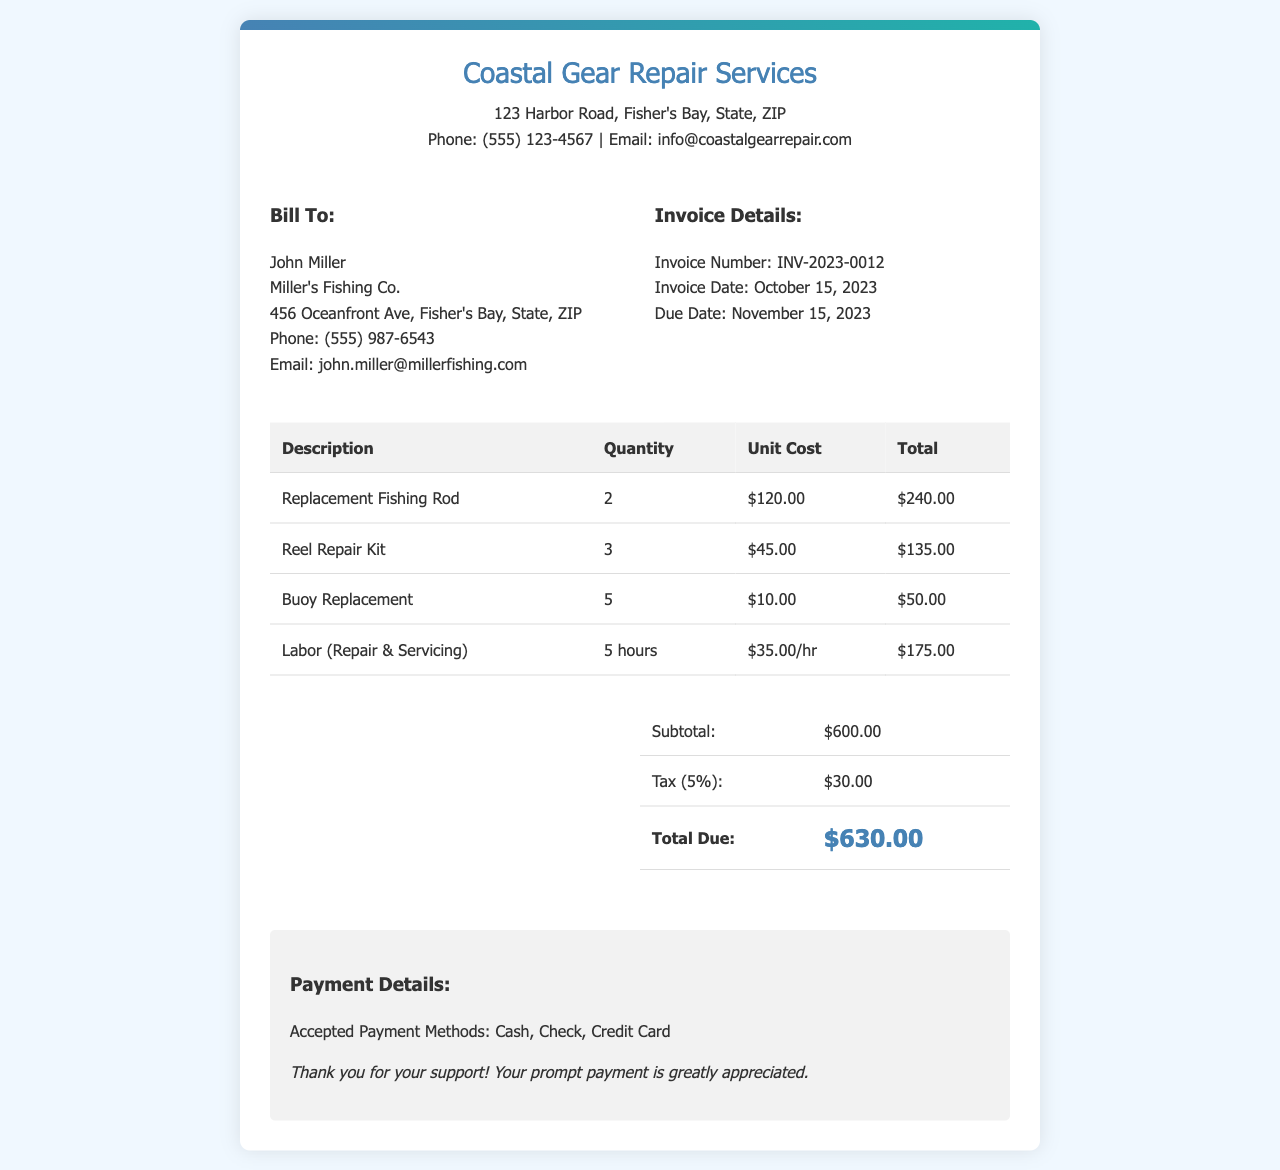What is the invoice number? The invoice number is listed in the invoice details section, identifying the document specifically.
Answer: INV-2023-0012 Who is the bill to? This specifies the recipient of the invoice and includes their name and company.
Answer: John Miller What is the total due amount? The total due is the amount that needs to be paid, including subtotal and tax.
Answer: $630.00 How much does the labor cost per hour? This is the rate charged for labor, specified in the itemized list of services.
Answer: $35.00/hr What is the subtotal before tax? The subtotal reflects the total cost of parts and labor before tax is added.
Answer: $600.00 What is the tax percentage applied? The tax is stated in the summary section and is calculated based on the subtotal.
Answer: 5% How many replacement fishing rods were billed? This refers to the quantity of a specific item billed in the invoice.
Answer: 2 What is the date of the invoice? This is the official issuance date of the invoice, which is important for payment tracking.
Answer: October 15, 2023 What company issued this invoice? This identifies the service provider who prepared the invoice.
Answer: Coastal Gear Repair Services 